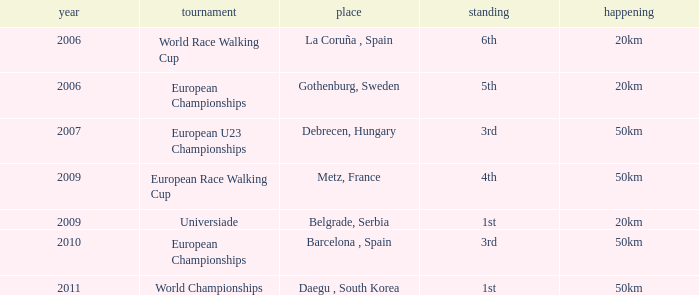Parse the table in full. {'header': ['year', 'tournament', 'place', 'standing', 'happening'], 'rows': [['2006', 'World Race Walking Cup', 'La Coruña , Spain', '6th', '20km'], ['2006', 'European Championships', 'Gothenburg, Sweden', '5th', '20km'], ['2007', 'European U23 Championships', 'Debrecen, Hungary', '3rd', '50km'], ['2009', 'European Race Walking Cup', 'Metz, France', '4th', '50km'], ['2009', 'Universiade', 'Belgrade, Serbia', '1st', '20km'], ['2010', 'European Championships', 'Barcelona , Spain', '3rd', '50km'], ['2011', 'World Championships', 'Daegu , South Korea', '1st', '50km']]} What Position is listed against a Venue of Debrecen, Hungary 3rd. 